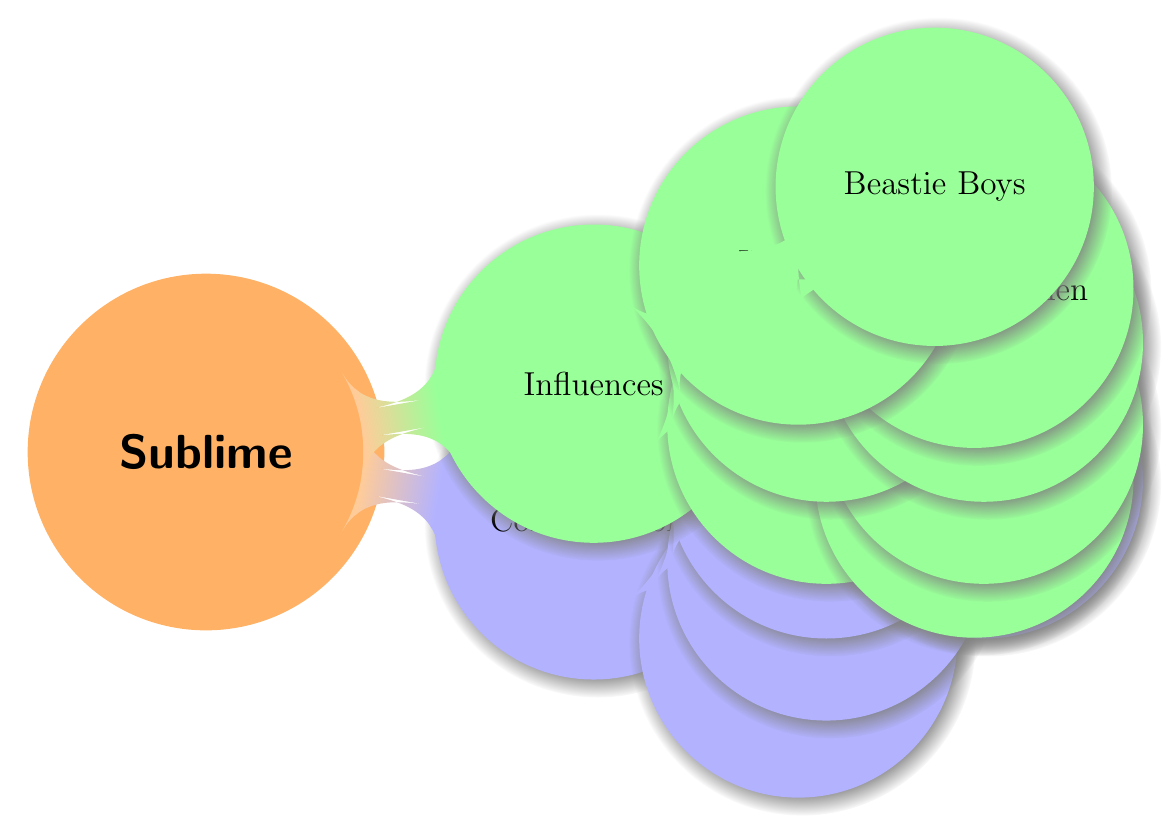What collaboration is associated with Snoop Dogg? The diagram specifies that Snoop Dogg collaborated on the track "Doin' Time," which was inspired by a Gershwin classic.
Answer: Doin' Time How many collaborators are listed in the diagram? There are three collaborators listed: Snoop Dogg, No Doubt, and Brad Nowell.
Answer: 3 Who did Sublime cover a song by? The diagram indicates that Sublime covered the Descendents' song "Hope."
Answer: Descendents Which reggae artist is mentioned as an influence? Bob Marley is highlighted in the diagram as a legendary reggae artist who influenced Sublime's sound.
Answer: Bob Marley In which genre is the "Beastie Boys" mentioned? The diagram shows that the Beastie Boys are included under the Hip Hop genre as an influence on Sublime's style.
Answer: Hip Hop Which two bands influenced Sublime's punk rock sound? The diagram identifies The Descendents and The Minutemen as key influences on Sublime's punk sound.
Answer: The Descendents and The Minutemen Who performed a duet with Gwen Stefani? According to the diagram, Sublime's Brad Nowell recorded a duet titled "Saw Red" with Gwen Stefani.
Answer: Brad Nowell How many influences are associated with the Reggae and Ska category? The diagram lists Bob Marley and Toots and the Maytals as two influences within the Reggae and Ska category.
Answer: 2 What relationship do No Doubt and Sublime have? The diagram indicates that No Doubt worked together with Sublime during the 1990s and performed live shows together.
Answer: Worked together and performed live shows 